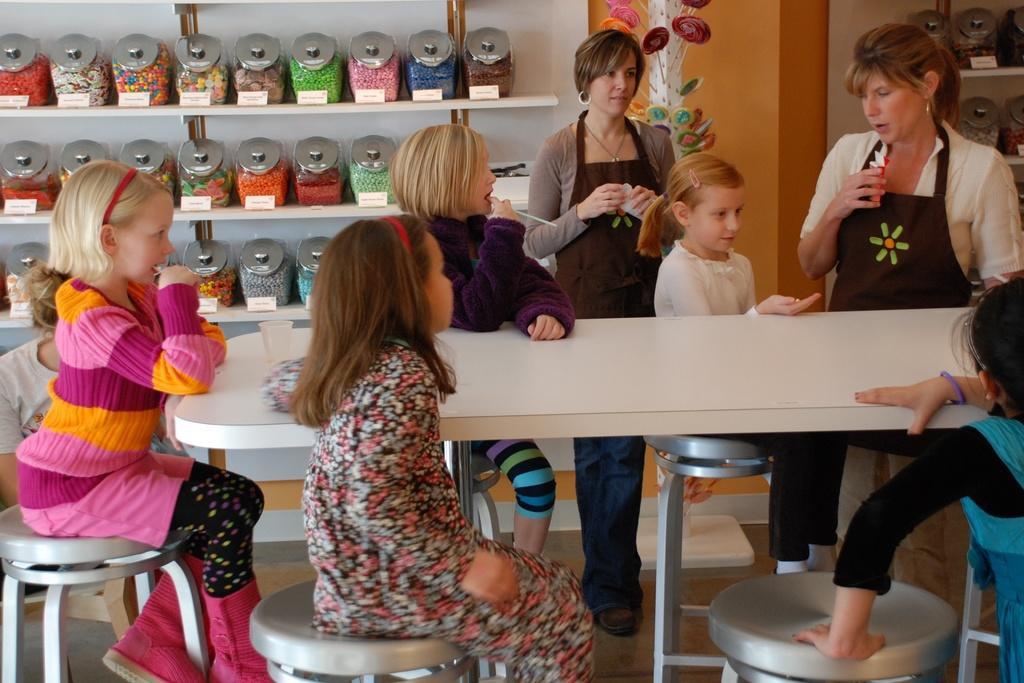Describe this image in one or two sentences. In this picture we can see two woman standing and children's sitting on stool and in front of them there is table and on table we have glass and beside to them we have jars with jams in it on racks, wall. 